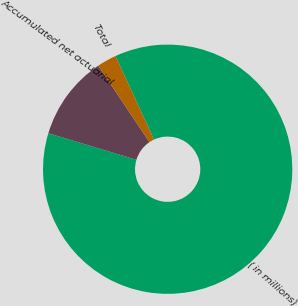Convert chart. <chart><loc_0><loc_0><loc_500><loc_500><pie_chart><fcel>( in millions)<fcel>Accumulated net actuarial<fcel>Total<nl><fcel>86.54%<fcel>10.93%<fcel>2.53%<nl></chart> 